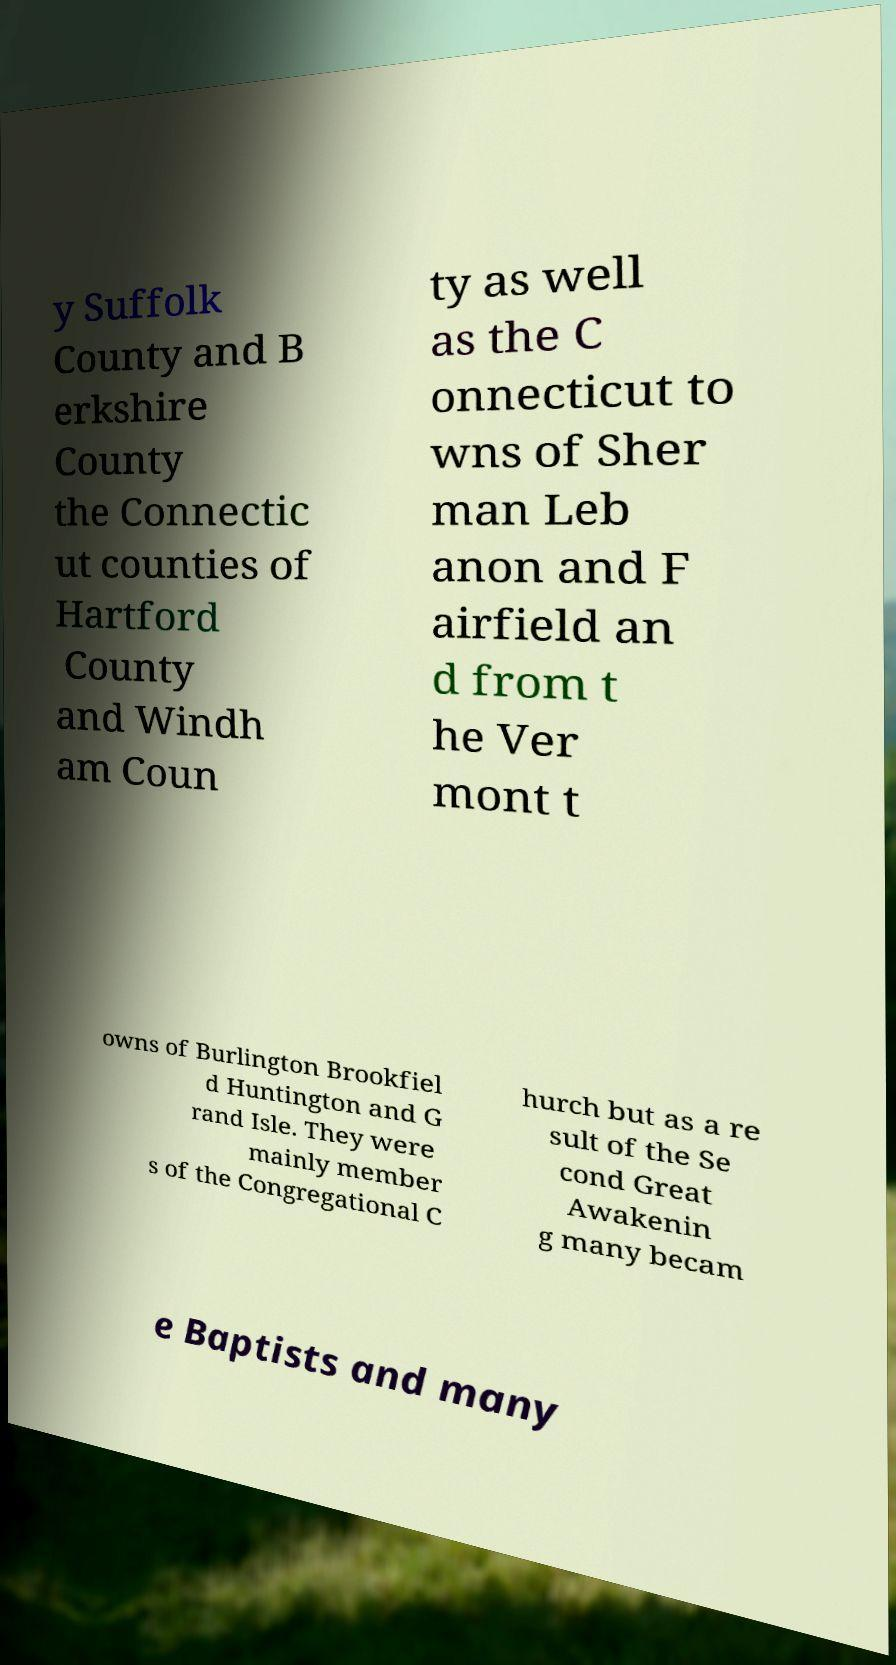What messages or text are displayed in this image? I need them in a readable, typed format. y Suffolk County and B erkshire County the Connectic ut counties of Hartford County and Windh am Coun ty as well as the C onnecticut to wns of Sher man Leb anon and F airfield an d from t he Ver mont t owns of Burlington Brookfiel d Huntington and G rand Isle. They were mainly member s of the Congregational C hurch but as a re sult of the Se cond Great Awakenin g many becam e Baptists and many 